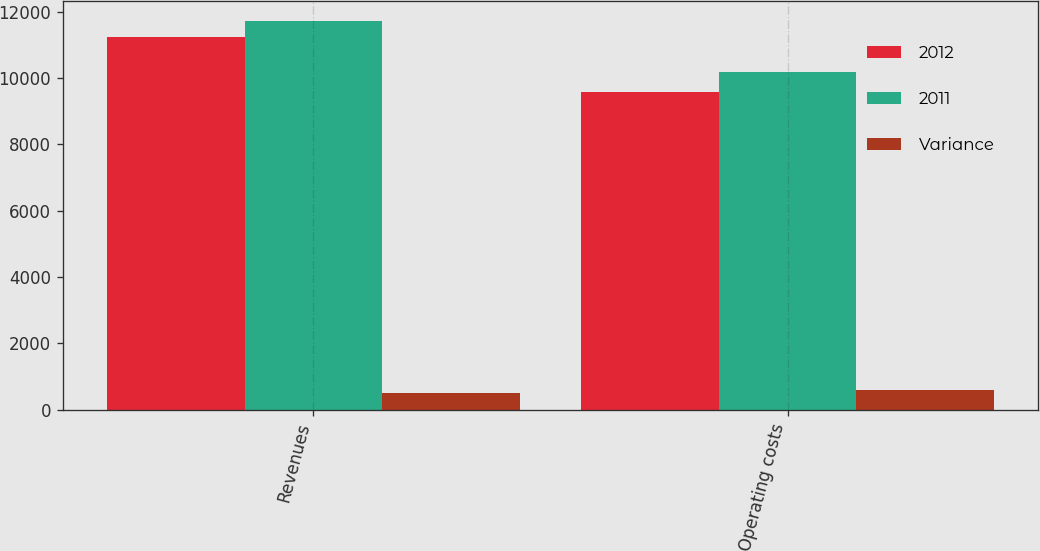<chart> <loc_0><loc_0><loc_500><loc_500><stacked_bar_chart><ecel><fcel>Revenues<fcel>Operating costs<nl><fcel>2012<fcel>11237<fcel>9591<nl><fcel>2011<fcel>11729<fcel>10182<nl><fcel>Variance<fcel>492<fcel>591<nl></chart> 